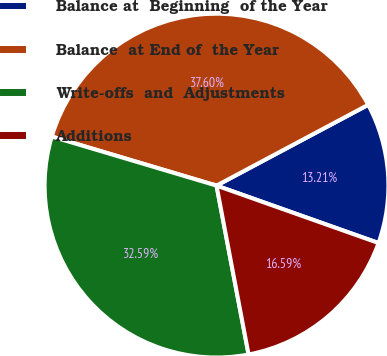Convert chart to OTSL. <chart><loc_0><loc_0><loc_500><loc_500><pie_chart><fcel>Balance at  Beginning  of the Year<fcel>Balance  at End of  the Year<fcel>Write-offs  and  Adjustments<fcel>Additions<nl><fcel>13.21%<fcel>37.6%<fcel>32.59%<fcel>16.59%<nl></chart> 